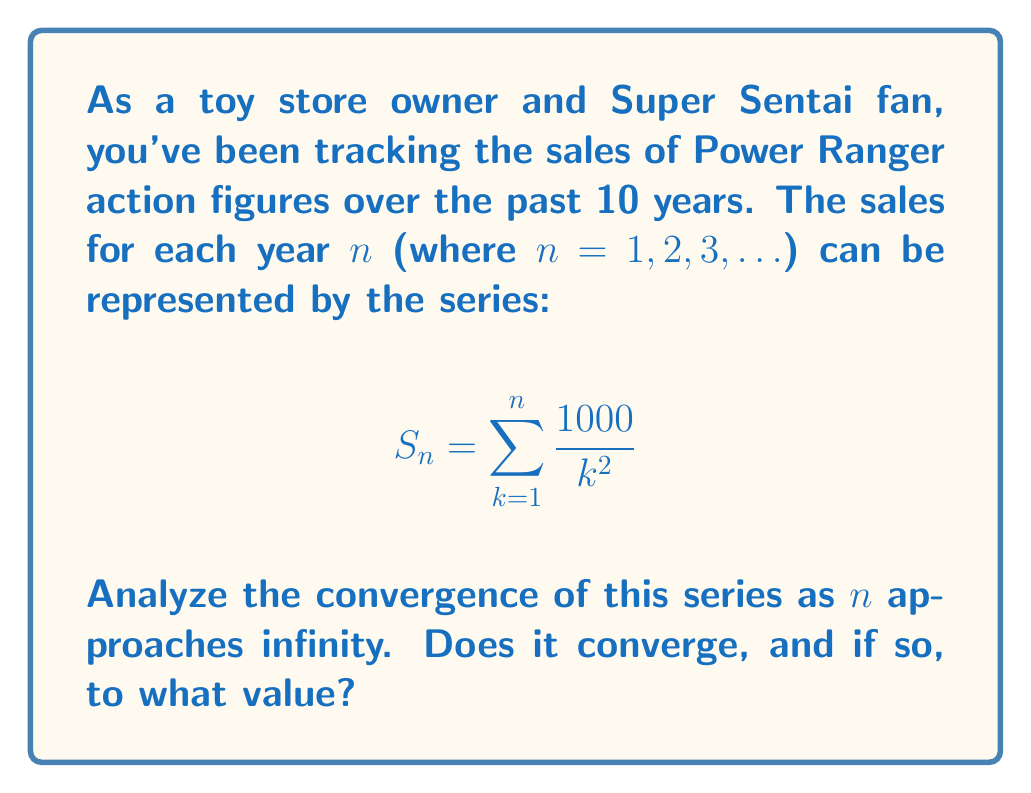What is the answer to this math problem? Let's approach this step-by-step:

1) First, we need to recognize that this series is of the form:

   $$ \sum_{k=1}^{\infty} \frac{1000}{k^2} = 1000 \sum_{k=1}^{\infty} \frac{1}{k^2} $$

2) The series $\sum_{k=1}^{\infty} \frac{1}{k^2}$ is a well-known series called the Basel problem.

3) We can use the p-series test to determine convergence. For a p-series $\sum_{k=1}^{\infty} \frac{1}{k^p}$:
   - If p > 1, the series converges
   - If p ≤ 1, the series diverges

4) In our case, p = 2, which is greater than 1, so the series converges.

5) The exact sum of the Basel problem was famously solved by Euler:

   $$ \sum_{k=1}^{\infty} \frac{1}{k^2} = \frac{\pi^2}{6} $$

6) Therefore, our series converges to:

   $$ 1000 \sum_{k=1}^{\infty} \frac{1}{k^2} = 1000 \cdot \frac{\pi^2}{6} = \frac{1000\pi^2}{6} $$

7) We can calculate this value:

   $$ \frac{1000\pi^2}{6} \approx 1644.93 $$

Thus, the series converges to approximately 1644.93.
Answer: The series converges to $\frac{1000\pi^2}{6}$ ≈ 1644.93. 